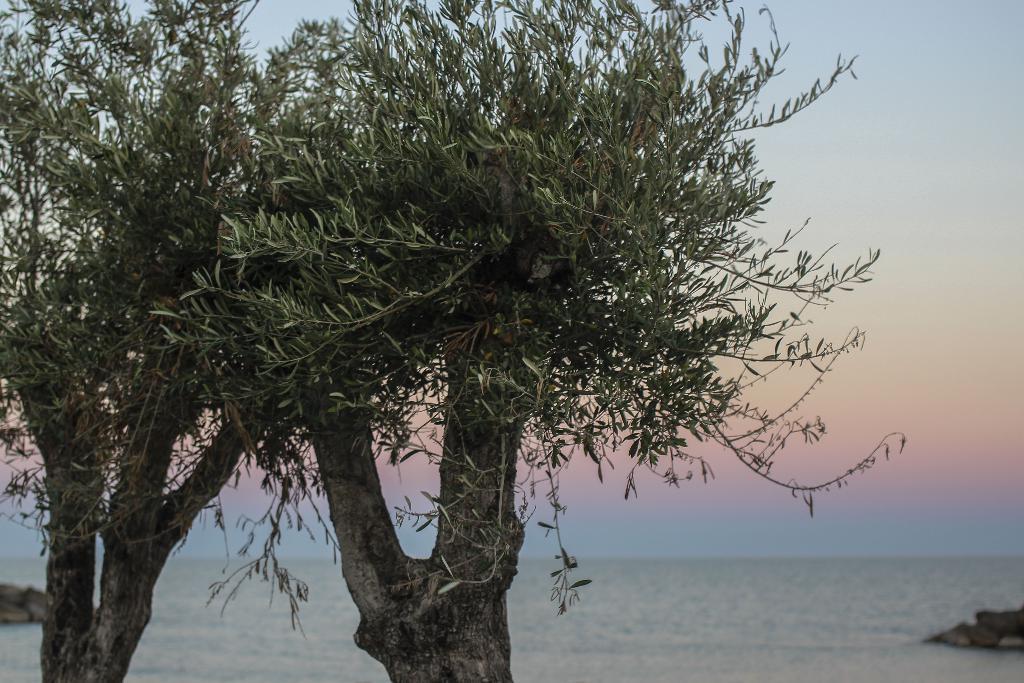In one or two sentences, can you explain what this image depicts? On the left side of the image we can see the tree. In the middle of the image we can see the tree and water body. On the right side of the image we can see the sky, water body and rocks. 